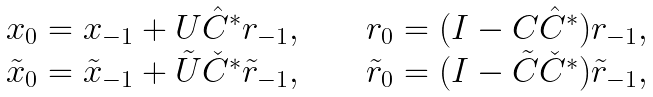Convert formula to latex. <formula><loc_0><loc_0><loc_500><loc_500>\begin{array} { l c r } x _ { 0 } = x _ { - 1 } + U \hat { C } ^ { * } r _ { - 1 } , & \quad & r _ { 0 } = ( I - C \hat { C } ^ { * } ) r _ { - 1 } , \\ \tilde { x } _ { 0 } = \tilde { x } _ { - 1 } + \tilde { U } \check { C } ^ { * } \tilde { r } _ { - 1 } , & \quad & \tilde { r } _ { 0 } = ( I - \tilde { C } \check { C } ^ { * } ) \tilde { r } _ { - 1 } , \end{array}</formula> 